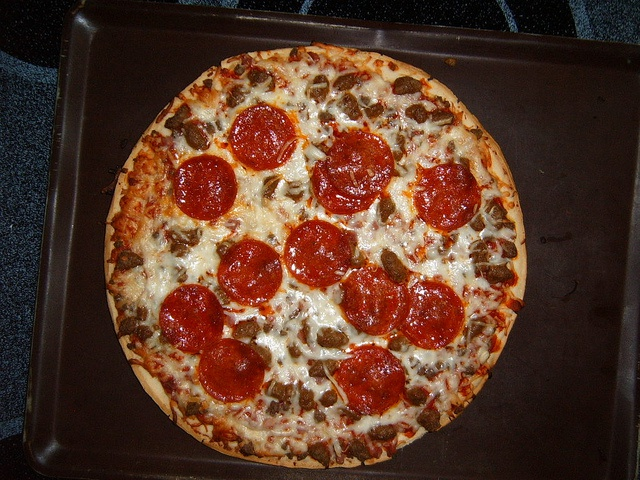Describe the objects in this image and their specific colors. I can see pizza in black, maroon, brown, and tan tones and oven in black, blue, and darkblue tones in this image. 